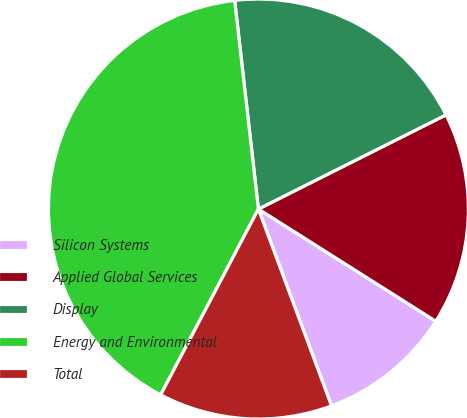Convert chart. <chart><loc_0><loc_0><loc_500><loc_500><pie_chart><fcel>Silicon Systems<fcel>Applied Global Services<fcel>Display<fcel>Energy and Environmental<fcel>Total<nl><fcel>10.36%<fcel>16.38%<fcel>19.4%<fcel>40.49%<fcel>13.37%<nl></chart> 